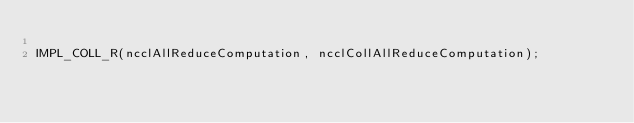Convert code to text. <code><loc_0><loc_0><loc_500><loc_500><_Cuda_>
IMPL_COLL_R(ncclAllReduceComputation, ncclCollAllReduceComputation);
</code> 